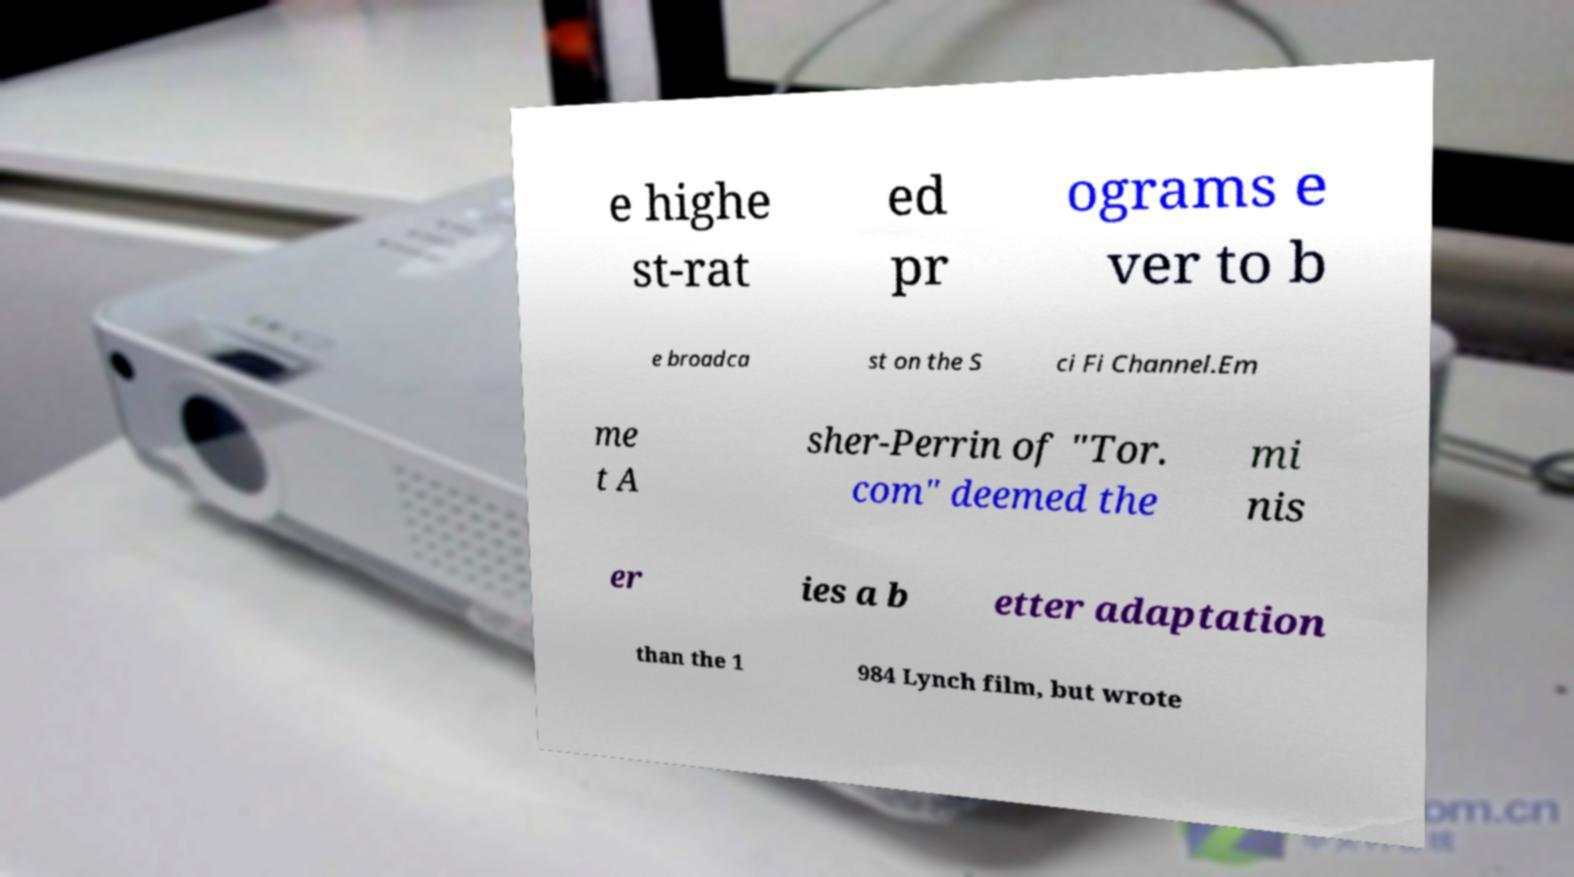Please read and relay the text visible in this image. What does it say? e highe st-rat ed pr ograms e ver to b e broadca st on the S ci Fi Channel.Em me t A sher-Perrin of "Tor. com" deemed the mi nis er ies a b etter adaptation than the 1 984 Lynch film, but wrote 